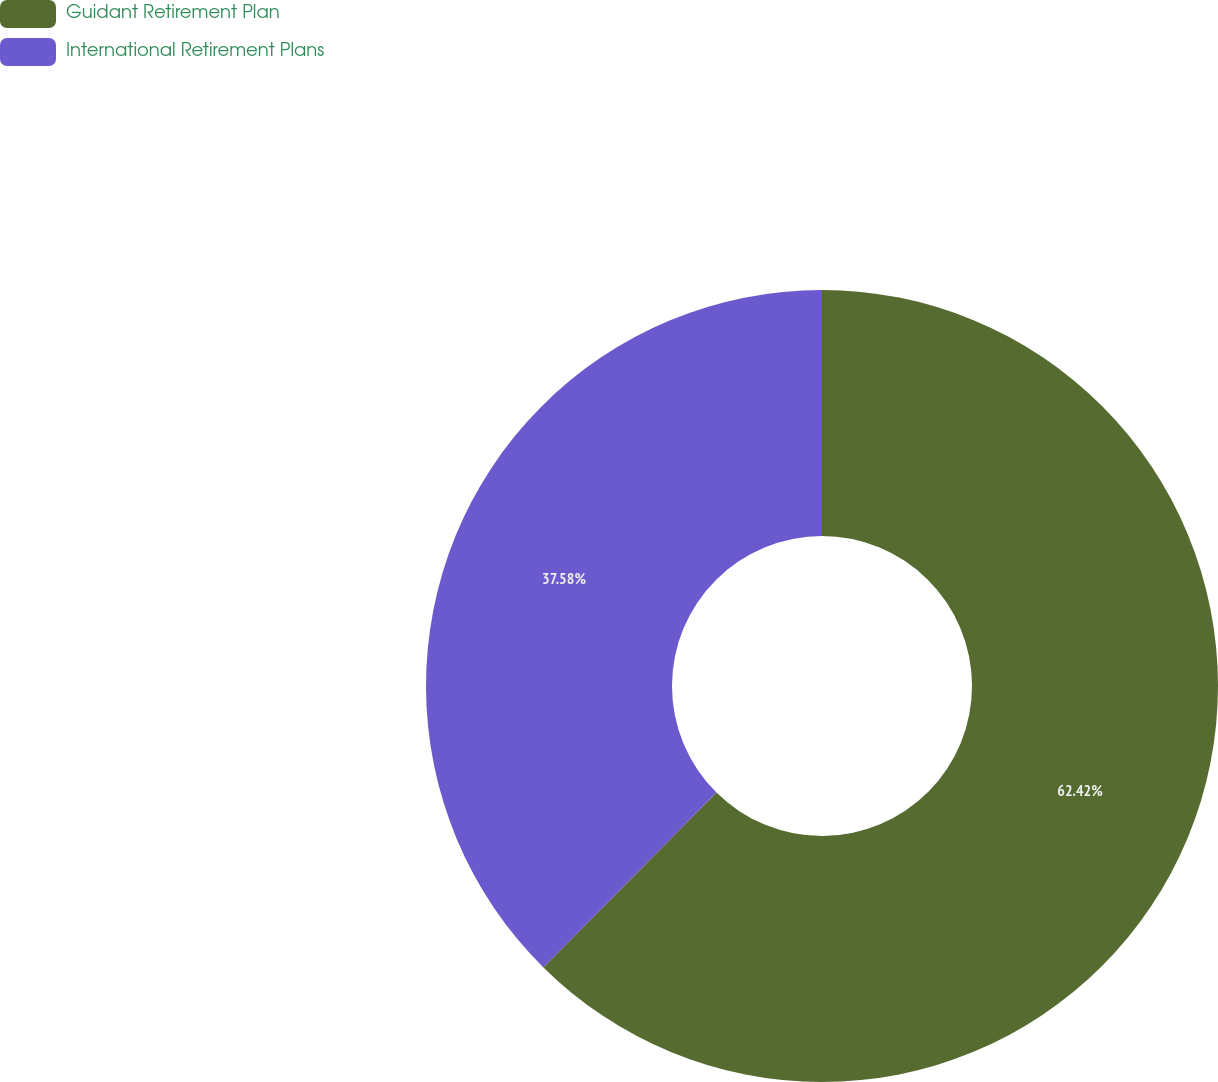Convert chart. <chart><loc_0><loc_0><loc_500><loc_500><pie_chart><fcel>Guidant Retirement Plan<fcel>International Retirement Plans<nl><fcel>62.42%<fcel>37.58%<nl></chart> 